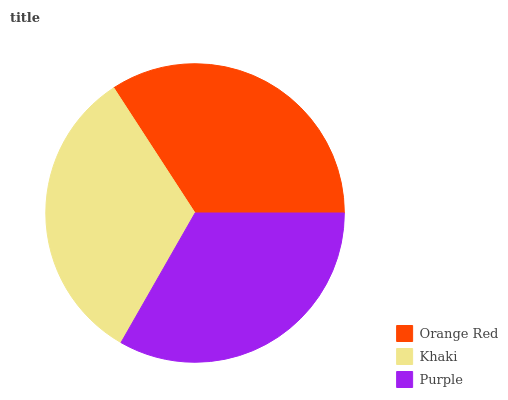Is Khaki the minimum?
Answer yes or no. Yes. Is Orange Red the maximum?
Answer yes or no. Yes. Is Purple the minimum?
Answer yes or no. No. Is Purple the maximum?
Answer yes or no. No. Is Purple greater than Khaki?
Answer yes or no. Yes. Is Khaki less than Purple?
Answer yes or no. Yes. Is Khaki greater than Purple?
Answer yes or no. No. Is Purple less than Khaki?
Answer yes or no. No. Is Purple the high median?
Answer yes or no. Yes. Is Purple the low median?
Answer yes or no. Yes. Is Orange Red the high median?
Answer yes or no. No. Is Khaki the low median?
Answer yes or no. No. 